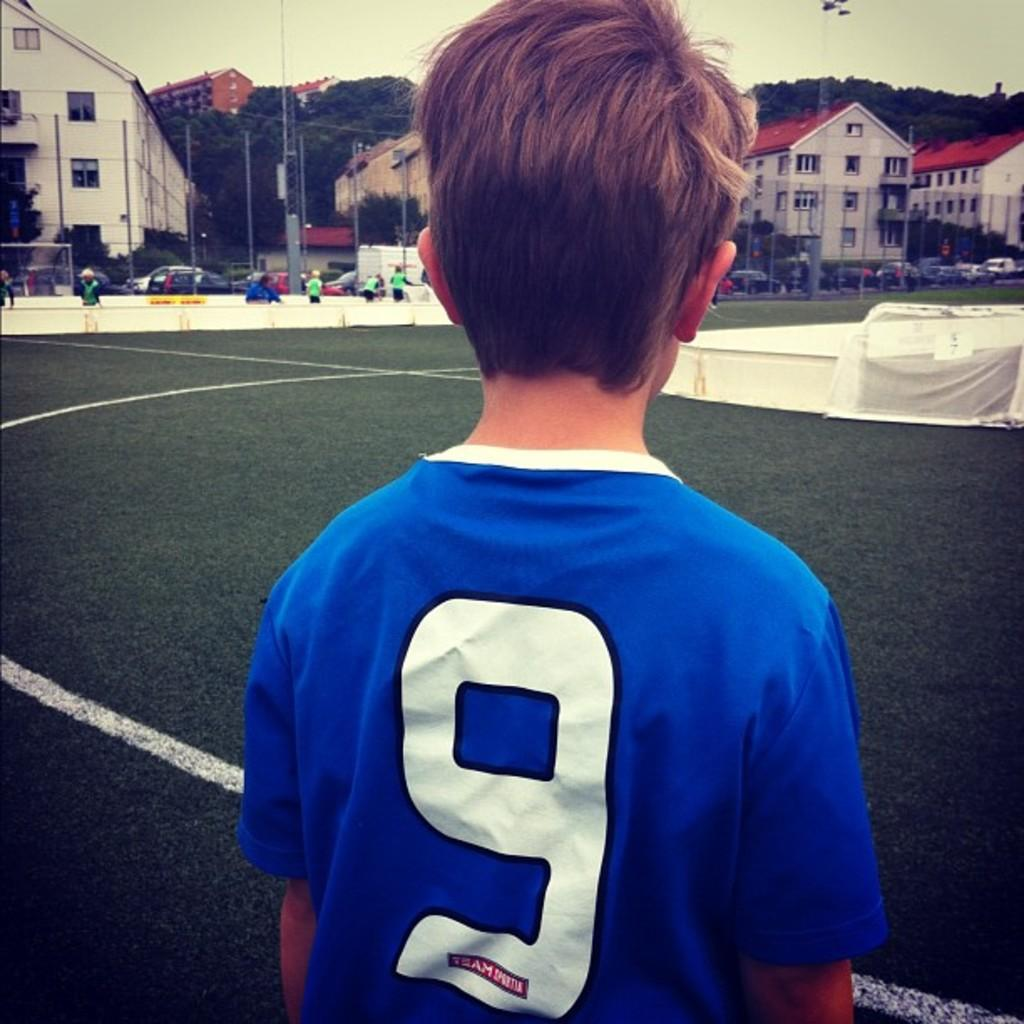<image>
Create a compact narrative representing the image presented. a child is on a soccer field wearing a blue jersey with the number 9. 